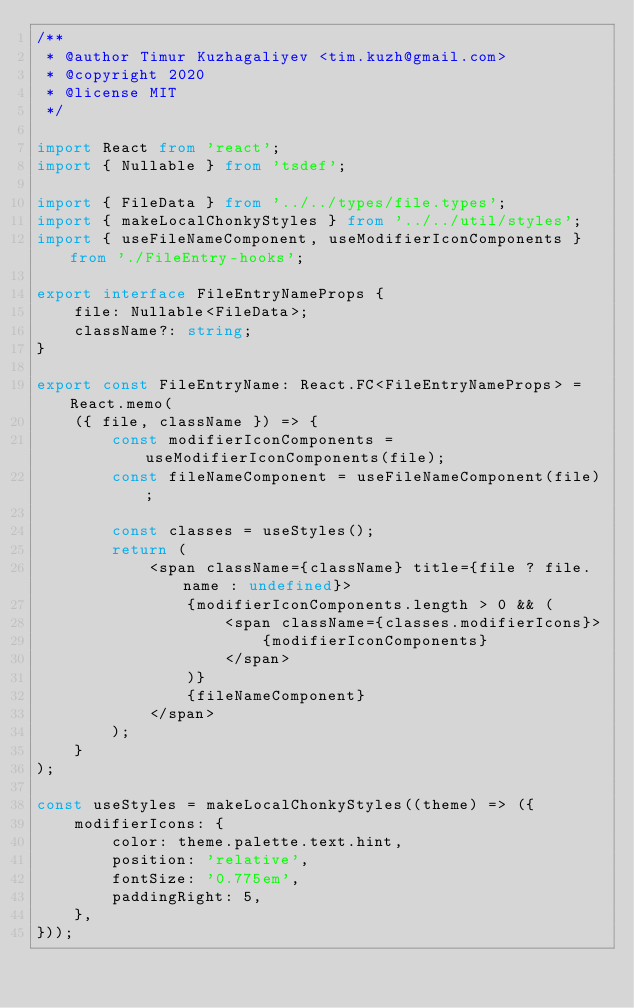Convert code to text. <code><loc_0><loc_0><loc_500><loc_500><_TypeScript_>/**
 * @author Timur Kuzhagaliyev <tim.kuzh@gmail.com>
 * @copyright 2020
 * @license MIT
 */

import React from 'react';
import { Nullable } from 'tsdef';

import { FileData } from '../../types/file.types';
import { makeLocalChonkyStyles } from '../../util/styles';
import { useFileNameComponent, useModifierIconComponents } from './FileEntry-hooks';

export interface FileEntryNameProps {
    file: Nullable<FileData>;
    className?: string;
}

export const FileEntryName: React.FC<FileEntryNameProps> = React.memo(
    ({ file, className }) => {
        const modifierIconComponents = useModifierIconComponents(file);
        const fileNameComponent = useFileNameComponent(file);

        const classes = useStyles();
        return (
            <span className={className} title={file ? file.name : undefined}>
                {modifierIconComponents.length > 0 && (
                    <span className={classes.modifierIcons}>
                        {modifierIconComponents}
                    </span>
                )}
                {fileNameComponent}
            </span>
        );
    }
);

const useStyles = makeLocalChonkyStyles((theme) => ({
    modifierIcons: {
        color: theme.palette.text.hint,
        position: 'relative',
        fontSize: '0.775em',
        paddingRight: 5,
    },
}));
</code> 